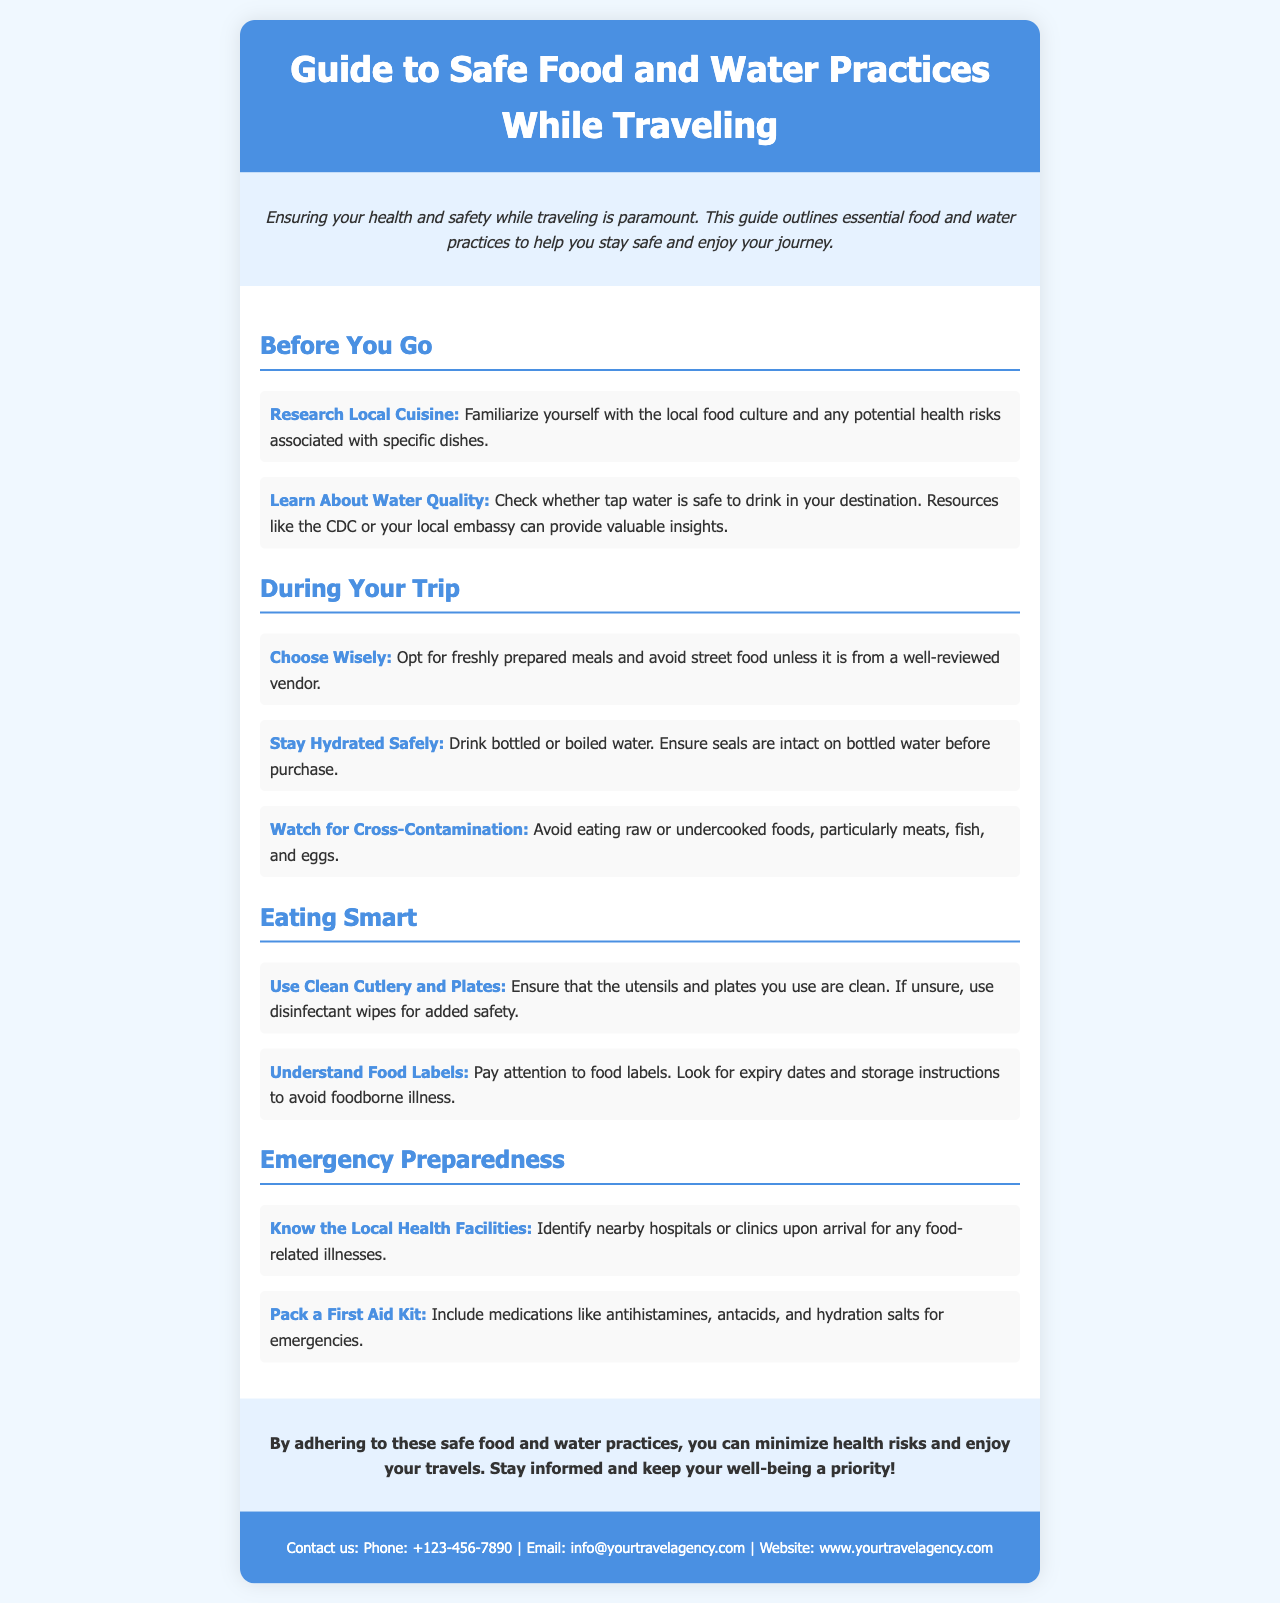What is the title of the brochure? The title of the brochure is presented prominently at the top.
Answer: Guide to Safe Food and Water Practices While Traveling What should you do about local cuisine before traveling? The document suggests familiarizing with local food culture and health risks.
Answer: Research Local Cuisine How should you hydrate safely during your trip? The brochure states the safest ways to hydrate while traveling.
Answer: Drink bottled or boiled water What is one of the recommended practices to prevent cross-contamination? The document outlines key practices for safe eating.
Answer: Avoid eating raw or undercooked foods What should you pack for emergencies while traveling? The brochure encourages preparation by suggesting what items to include.
Answer: Pack a First Aid Kit How can you ensure cleanliness when eating? The document provides advice on maintaining hygiene while eating.
Answer: Use Clean Cutlery and Plates What is advised to check on bottled water before purchase? The document highlights an important point regarding bottled water.
Answer: Ensure seals are intact What type of information can the CDC provide? The CDC is mentioned as a source for safe travel information.
Answer: Water Quality What is the main purpose of this brochure? The document’s introduction states its primary objective.
Answer: Ensure your health and safety while traveling 